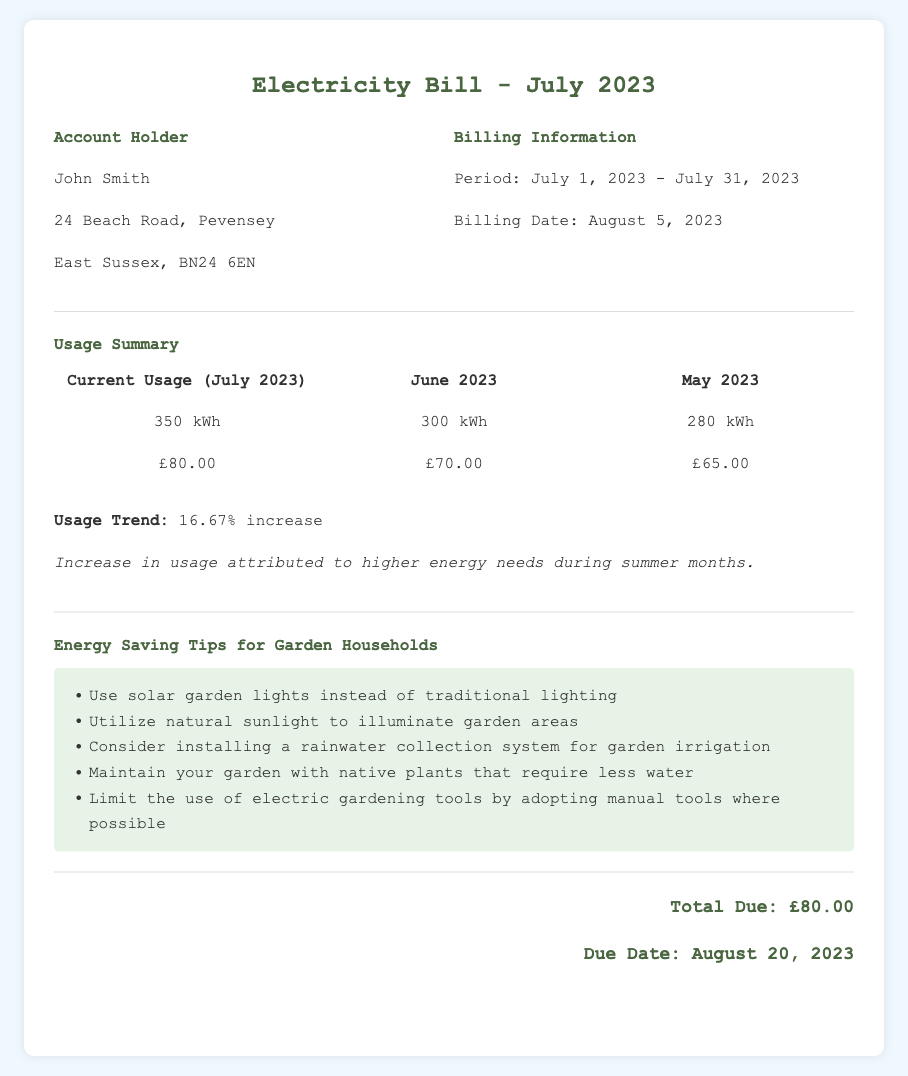What is the account holder's name? The account holder's name is provided in the document.
Answer: John Smith What was the total usage in July 2023? The document specifies the current usage for July 2023.
Answer: 350 kWh How much is the total due for this bill? The total due is clearly stated in the document.
Answer: £80.00 What percentage increase was observed in usage compared to the previous month? The document mentions the usage trend and the percentage increase.
Answer: 16.67% What is one energy-saving tip mentioned for households with gardens? The document lists several energy-saving tips for garden households.
Answer: Use solar garden lights instead of traditional lighting What was the billing period for this electricity bill? The document states the specific billing period for the usage.
Answer: July 1, 2023 - July 31, 2023 How many kilowatt hours did the household use in June 2023? The document provides usage details for multiple months, including June.
Answer: 300 kWh What is the due date for this bill? The document specifies when the total amount is due.
Answer: August 20, 2023 